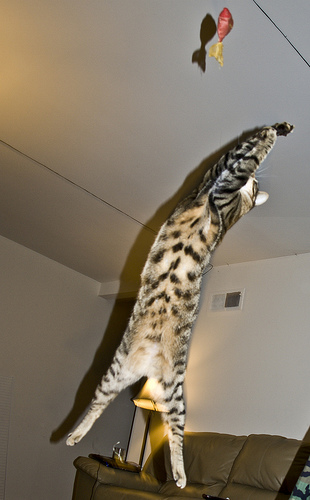<image>
Is there a cat on the ceiling? No. The cat is not positioned on the ceiling. They may be near each other, but the cat is not supported by or resting on top of the ceiling. 